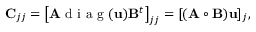<formula> <loc_0><loc_0><loc_500><loc_500>C _ { j j } = \left [ A d i a g ( u ) B ^ { t } \right ] _ { j j } = [ ( A \circ B ) u ] _ { j } ,</formula> 